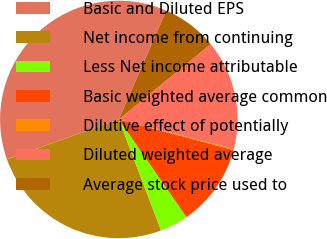<chart> <loc_0><loc_0><loc_500><loc_500><pie_chart><fcel>Basic and Diluted EPS<fcel>Net income from continuing<fcel>Less Net income attributable<fcel>Basic weighted average common<fcel>Dilutive effect of potentially<fcel>Diluted weighted average<fcel>Average stock price used to<nl><fcel>37.0%<fcel>25.34%<fcel>3.85%<fcel>11.21%<fcel>0.17%<fcel>14.9%<fcel>7.53%<nl></chart> 